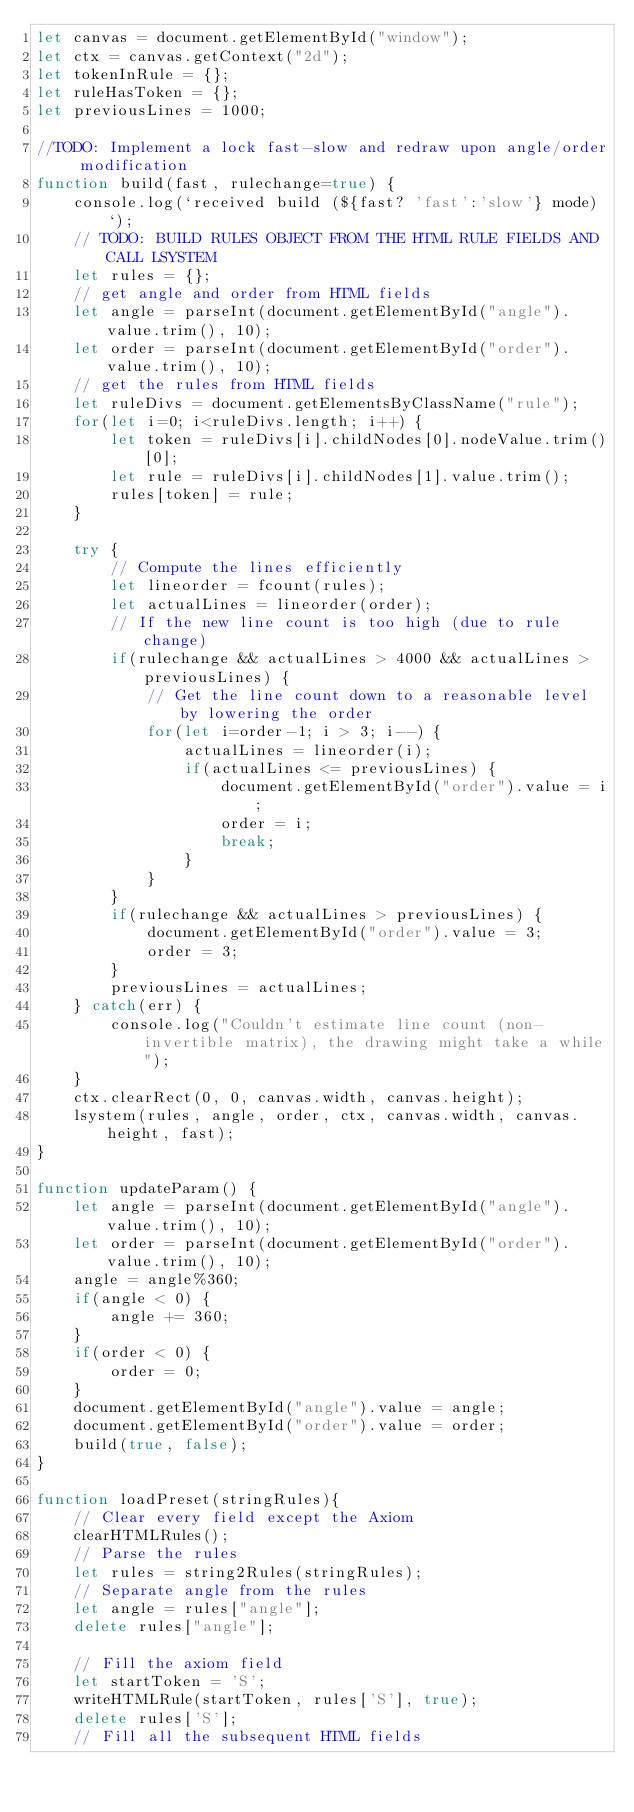Convert code to text. <code><loc_0><loc_0><loc_500><loc_500><_JavaScript_>let canvas = document.getElementById("window");
let ctx = canvas.getContext("2d");
let tokenInRule = {};
let ruleHasToken = {};
let previousLines = 1000;

//TODO: Implement a lock fast-slow and redraw upon angle/order modification
function build(fast, rulechange=true) {
    console.log(`received build (${fast? 'fast':'slow'} mode)`);
    // TODO: BUILD RULES OBJECT FROM THE HTML RULE FIELDS AND CALL LSYSTEM
    let rules = {};
    // get angle and order from HTML fields
    let angle = parseInt(document.getElementById("angle").value.trim(), 10);
    let order = parseInt(document.getElementById("order").value.trim(), 10);
    // get the rules from HTML fields
    let ruleDivs = document.getElementsByClassName("rule");
    for(let i=0; i<ruleDivs.length; i++) {
        let token = ruleDivs[i].childNodes[0].nodeValue.trim()[0];
        let rule = ruleDivs[i].childNodes[1].value.trim();
        rules[token] = rule;
    }

    try {
        // Compute the lines efficiently
        let lineorder = fcount(rules);
        let actualLines = lineorder(order);
        // If the new line count is too high (due to rule change)
        if(rulechange && actualLines > 4000 && actualLines > previousLines) {
            // Get the line count down to a reasonable level by lowering the order
            for(let i=order-1; i > 3; i--) {
                actualLines = lineorder(i);
                if(actualLines <= previousLines) {
                    document.getElementById("order").value = i;
                    order = i;
                    break;
                }
            }
        }
        if(rulechange && actualLines > previousLines) {
            document.getElementById("order").value = 3;
            order = 3;
        }
        previousLines = actualLines;
    } catch(err) {
        console.log("Couldn't estimate line count (non-invertible matrix), the drawing might take a while");
    }
    ctx.clearRect(0, 0, canvas.width, canvas.height);
    lsystem(rules, angle, order, ctx, canvas.width, canvas.height, fast);
}

function updateParam() {
    let angle = parseInt(document.getElementById("angle").value.trim(), 10);
    let order = parseInt(document.getElementById("order").value.trim(), 10);
    angle = angle%360;
    if(angle < 0) {
        angle += 360;
    }
    if(order < 0) {
        order = 0;
    }
    document.getElementById("angle").value = angle;
    document.getElementById("order").value = order;
    build(true, false);
}

function loadPreset(stringRules){
    // Clear every field except the Axiom
    clearHTMLRules();
    // Parse the rules
    let rules = string2Rules(stringRules);
    // Separate angle from the rules
    let angle = rules["angle"];
    delete rules["angle"];

    // Fill the axiom field
    let startToken = 'S';
    writeHTMLRule(startToken, rules['S'], true);
    delete rules['S'];
    // Fill all the subsequent HTML fields</code> 